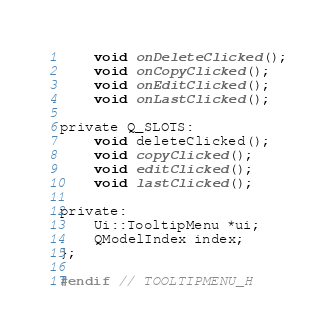<code> <loc_0><loc_0><loc_500><loc_500><_C_>    void onDeleteClicked();
    void onCopyClicked();
    void onEditClicked();
    void onLastClicked();

private Q_SLOTS:
    void deleteClicked();
    void copyClicked();
    void editClicked();
    void lastClicked();

private:
    Ui::TooltipMenu *ui;
    QModelIndex index;
};

#endif // TOOLTIPMENU_H
</code> 